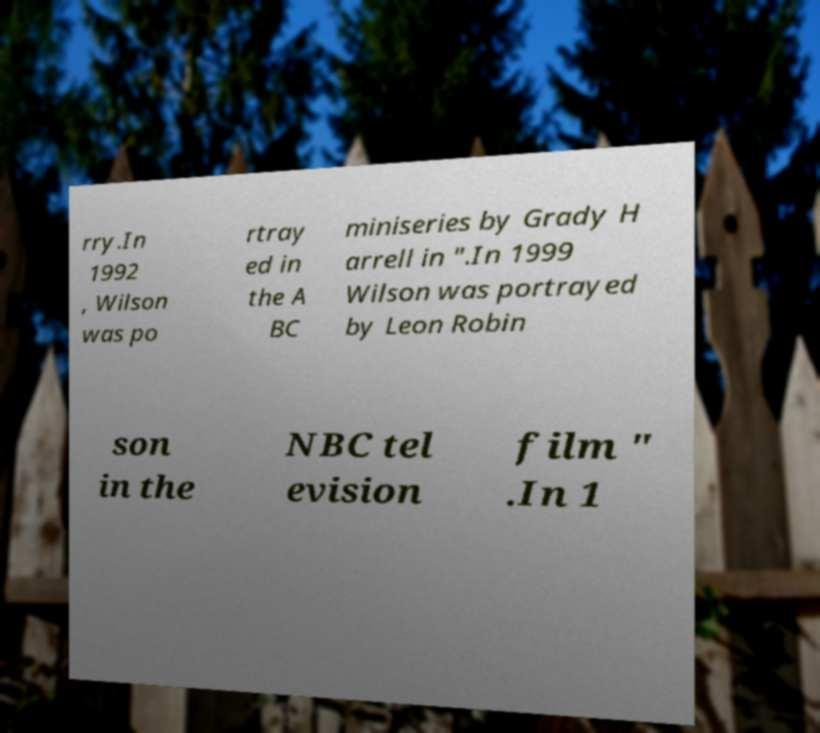Can you read and provide the text displayed in the image?This photo seems to have some interesting text. Can you extract and type it out for me? rry.In 1992 , Wilson was po rtray ed in the A BC miniseries by Grady H arrell in ".In 1999 Wilson was portrayed by Leon Robin son in the NBC tel evision film " .In 1 